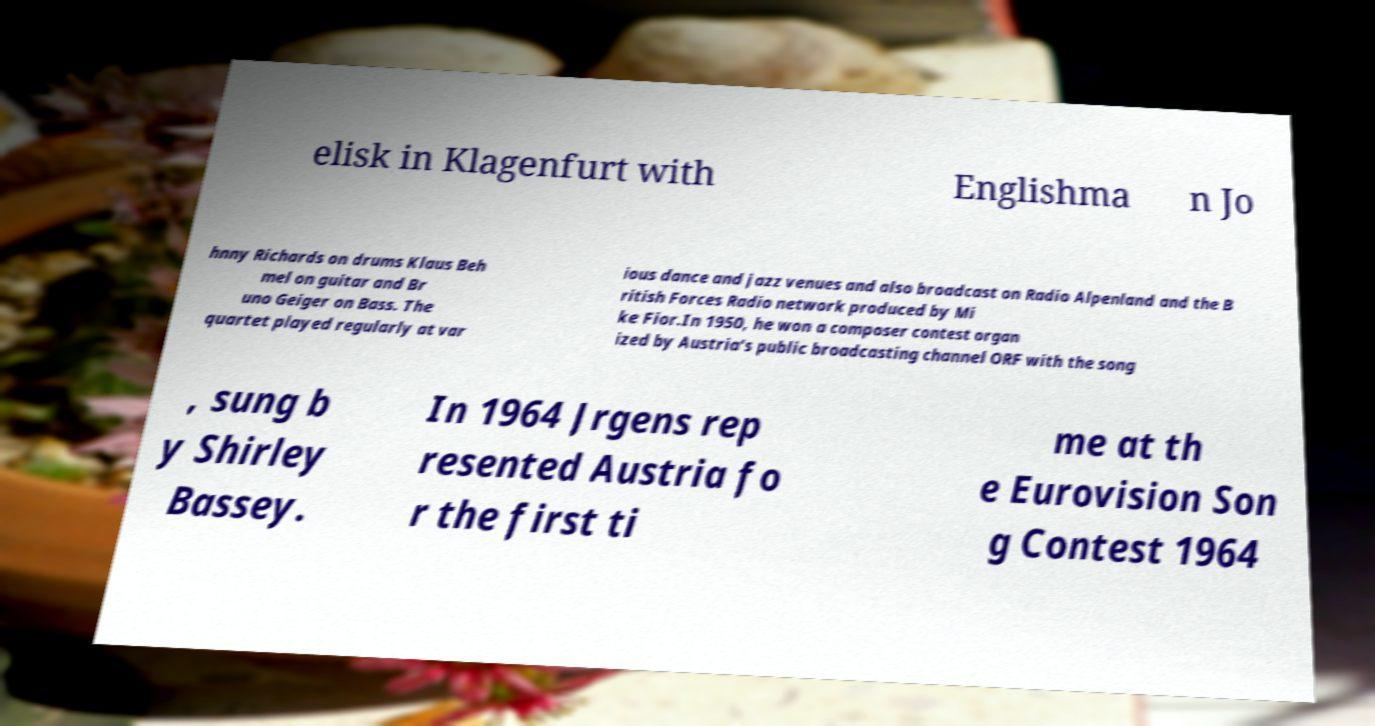Could you assist in decoding the text presented in this image and type it out clearly? elisk in Klagenfurt with Englishma n Jo hnny Richards on drums Klaus Beh mel on guitar and Br uno Geiger on Bass. The quartet played regularly at var ious dance and jazz venues and also broadcast on Radio Alpenland and the B ritish Forces Radio network produced by Mi ke Fior.In 1950, he won a composer contest organ ized by Austria's public broadcasting channel ORF with the song , sung b y Shirley Bassey. In 1964 Jrgens rep resented Austria fo r the first ti me at th e Eurovision Son g Contest 1964 